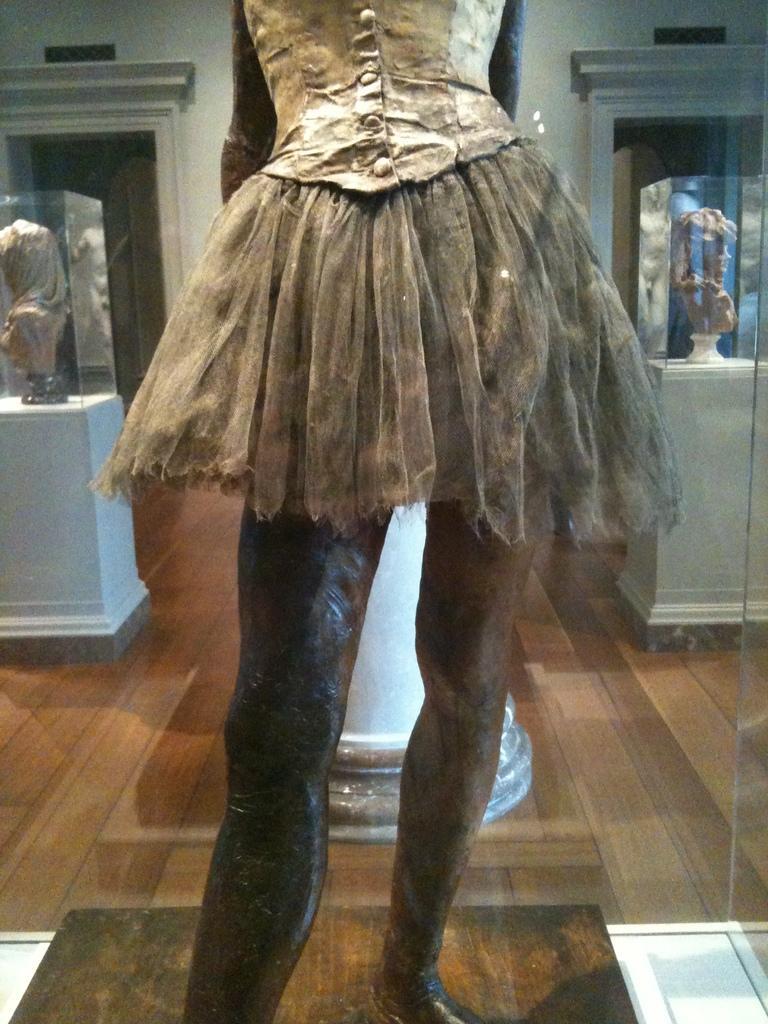Could you give a brief overview of what you see in this image? In this image, we can see a statue, floor and glass object. In the background, we can see glass boxes and wall. Through the glass boxes, we can see sculptures. 